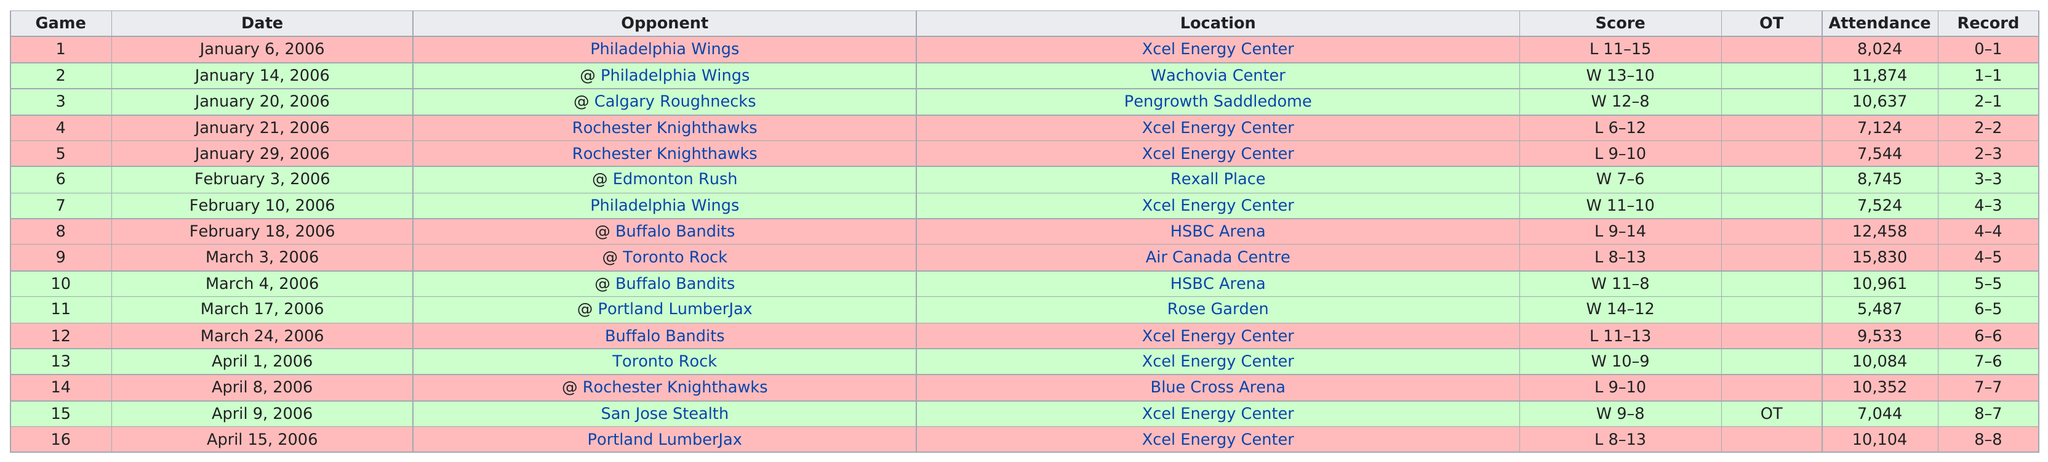Outline some significant characteristics in this image. I'm sorry, but the sentence you provided does not make sense in English. Could you please provide more context or rephrase the sentence so I can better understand what you are asking? The opponent for Game 2 was none other than the Philadelphia Wings. The most people attended the event on March 3, 2006. Eight home games were played in total. The score for Game 8 was 9-14, resulting in a loss. 